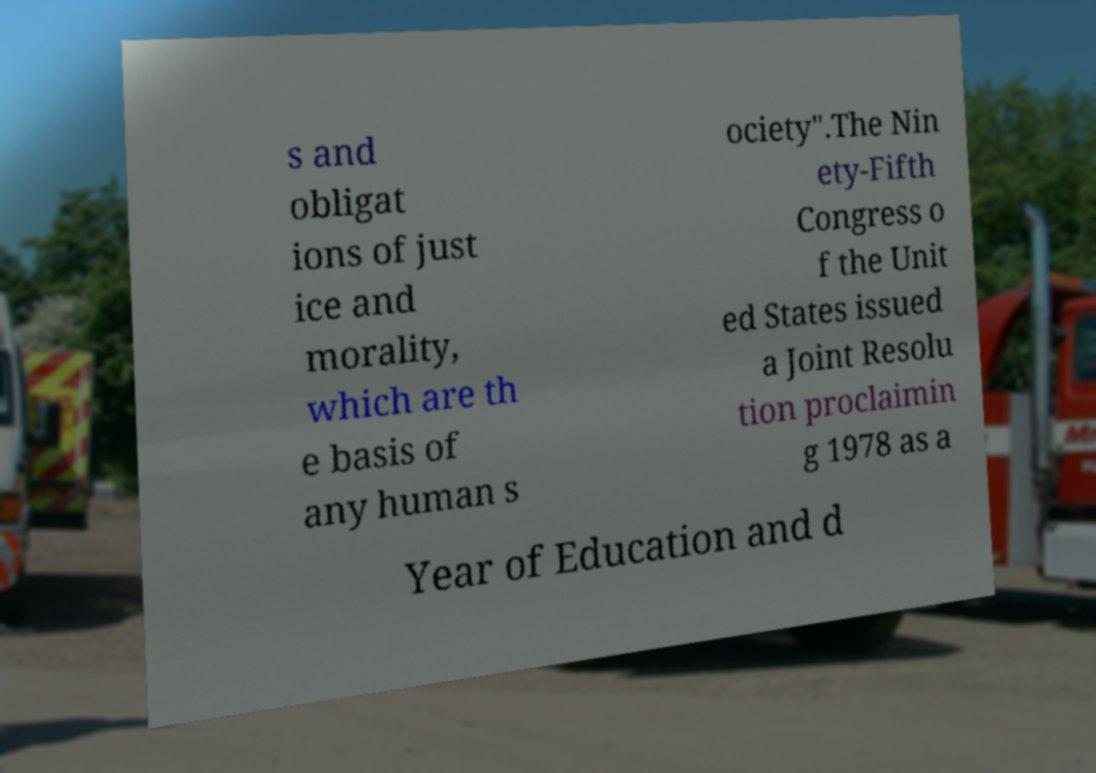Please identify and transcribe the text found in this image. s and obligat ions of just ice and morality, which are th e basis of any human s ociety".The Nin ety-Fifth Congress o f the Unit ed States issued a Joint Resolu tion proclaimin g 1978 as a Year of Education and d 